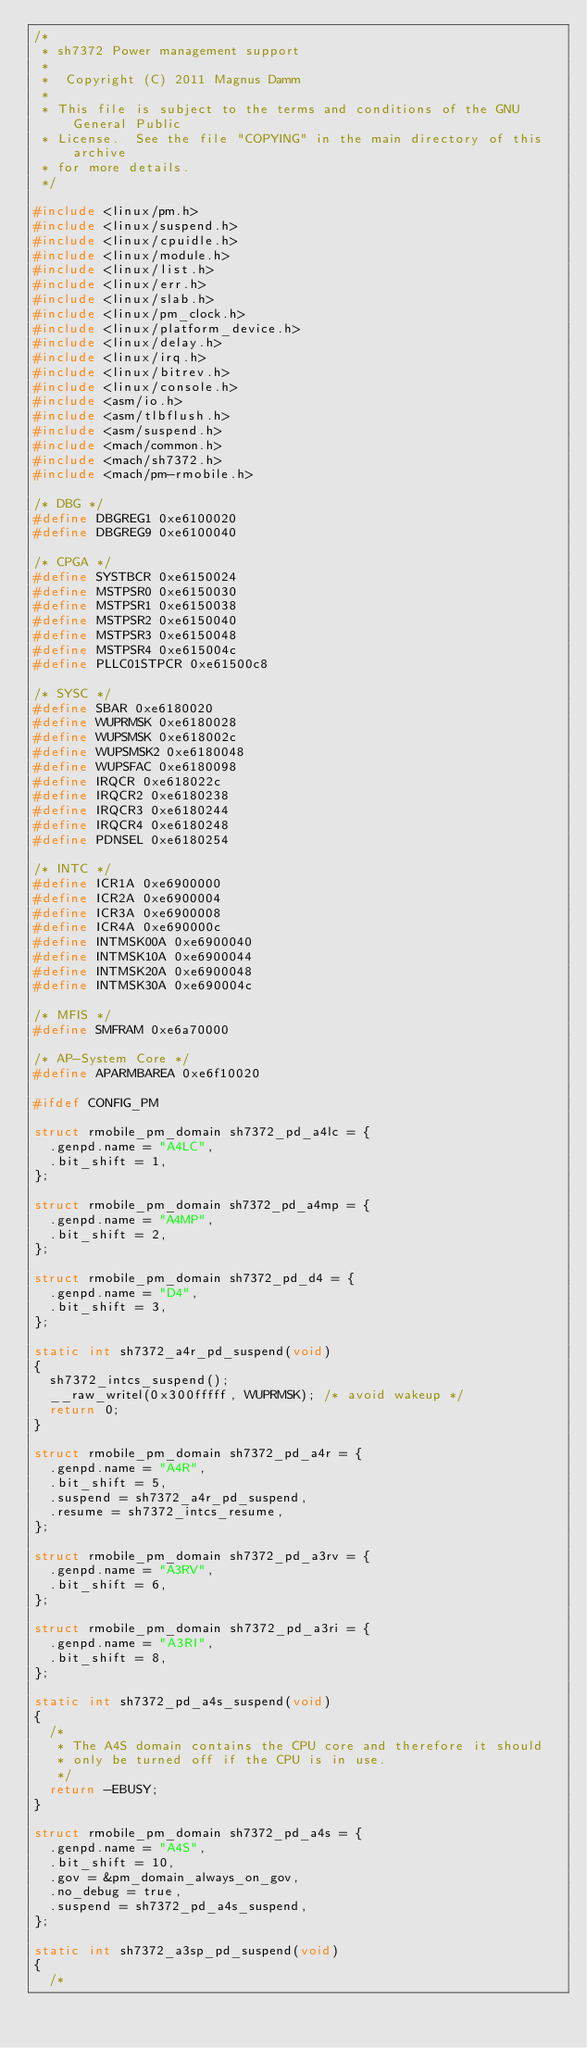Convert code to text. <code><loc_0><loc_0><loc_500><loc_500><_C_>/*
 * sh7372 Power management support
 *
 *  Copyright (C) 2011 Magnus Damm
 *
 * This file is subject to the terms and conditions of the GNU General Public
 * License.  See the file "COPYING" in the main directory of this archive
 * for more details.
 */

#include <linux/pm.h>
#include <linux/suspend.h>
#include <linux/cpuidle.h>
#include <linux/module.h>
#include <linux/list.h>
#include <linux/err.h>
#include <linux/slab.h>
#include <linux/pm_clock.h>
#include <linux/platform_device.h>
#include <linux/delay.h>
#include <linux/irq.h>
#include <linux/bitrev.h>
#include <linux/console.h>
#include <asm/io.h>
#include <asm/tlbflush.h>
#include <asm/suspend.h>
#include <mach/common.h>
#include <mach/sh7372.h>
#include <mach/pm-rmobile.h>

/* DBG */
#define DBGREG1 0xe6100020
#define DBGREG9 0xe6100040

/* CPGA */
#define SYSTBCR 0xe6150024
#define MSTPSR0 0xe6150030
#define MSTPSR1 0xe6150038
#define MSTPSR2 0xe6150040
#define MSTPSR3 0xe6150048
#define MSTPSR4 0xe615004c
#define PLLC01STPCR 0xe61500c8

/* SYSC */
#define SBAR 0xe6180020
#define WUPRMSK 0xe6180028
#define WUPSMSK 0xe618002c
#define WUPSMSK2 0xe6180048
#define WUPSFAC 0xe6180098
#define IRQCR 0xe618022c
#define IRQCR2 0xe6180238
#define IRQCR3 0xe6180244
#define IRQCR4 0xe6180248
#define PDNSEL 0xe6180254

/* INTC */
#define ICR1A 0xe6900000
#define ICR2A 0xe6900004
#define ICR3A 0xe6900008
#define ICR4A 0xe690000c
#define INTMSK00A 0xe6900040
#define INTMSK10A 0xe6900044
#define INTMSK20A 0xe6900048
#define INTMSK30A 0xe690004c

/* MFIS */
#define SMFRAM 0xe6a70000

/* AP-System Core */
#define APARMBAREA 0xe6f10020

#ifdef CONFIG_PM

struct rmobile_pm_domain sh7372_pd_a4lc = {
	.genpd.name = "A4LC",
	.bit_shift = 1,
};

struct rmobile_pm_domain sh7372_pd_a4mp = {
	.genpd.name = "A4MP",
	.bit_shift = 2,
};

struct rmobile_pm_domain sh7372_pd_d4 = {
	.genpd.name = "D4",
	.bit_shift = 3,
};

static int sh7372_a4r_pd_suspend(void)
{
	sh7372_intcs_suspend();
	__raw_writel(0x300fffff, WUPRMSK); /* avoid wakeup */
	return 0;
}

struct rmobile_pm_domain sh7372_pd_a4r = {
	.genpd.name = "A4R",
	.bit_shift = 5,
	.suspend = sh7372_a4r_pd_suspend,
	.resume = sh7372_intcs_resume,
};

struct rmobile_pm_domain sh7372_pd_a3rv = {
	.genpd.name = "A3RV",
	.bit_shift = 6,
};

struct rmobile_pm_domain sh7372_pd_a3ri = {
	.genpd.name = "A3RI",
	.bit_shift = 8,
};

static int sh7372_pd_a4s_suspend(void)
{
	/*
	 * The A4S domain contains the CPU core and therefore it should
	 * only be turned off if the CPU is in use.
	 */
	return -EBUSY;
}

struct rmobile_pm_domain sh7372_pd_a4s = {
	.genpd.name = "A4S",
	.bit_shift = 10,
	.gov = &pm_domain_always_on_gov,
	.no_debug = true,
	.suspend = sh7372_pd_a4s_suspend,
};

static int sh7372_a3sp_pd_suspend(void)
{
	/*</code> 